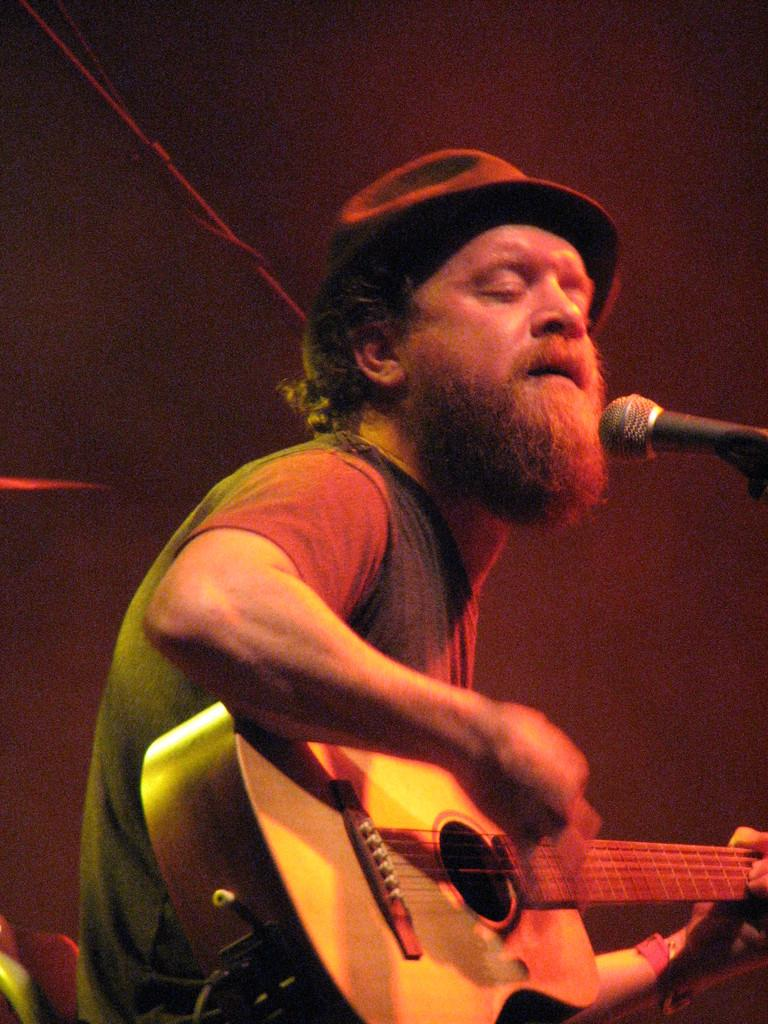What is the man in the image doing? The man is playing the guitar and singing a song. What object is the man holding in the image? The man is holding a guitar. What is the man wearing on his head? The man is wearing a black hat. What device is in front of the man? There is a microphone in front of the man. Where is the parcel that the man is supposed to deliver in the image? There is no parcel mentioned or visible in the image. What is the manager's opinion about the man's performance in the image? There is no manager present in the image, so it is impossible to determine their opinion. 